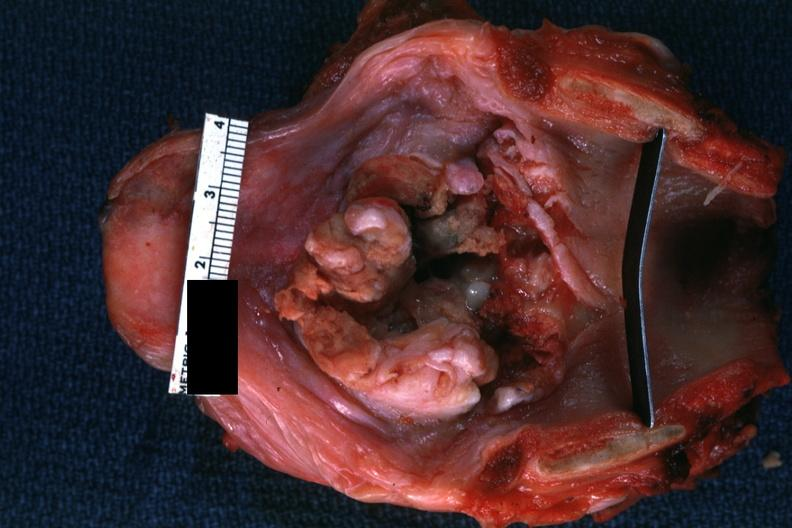s carcinoma present?
Answer the question using a single word or phrase. Yes 